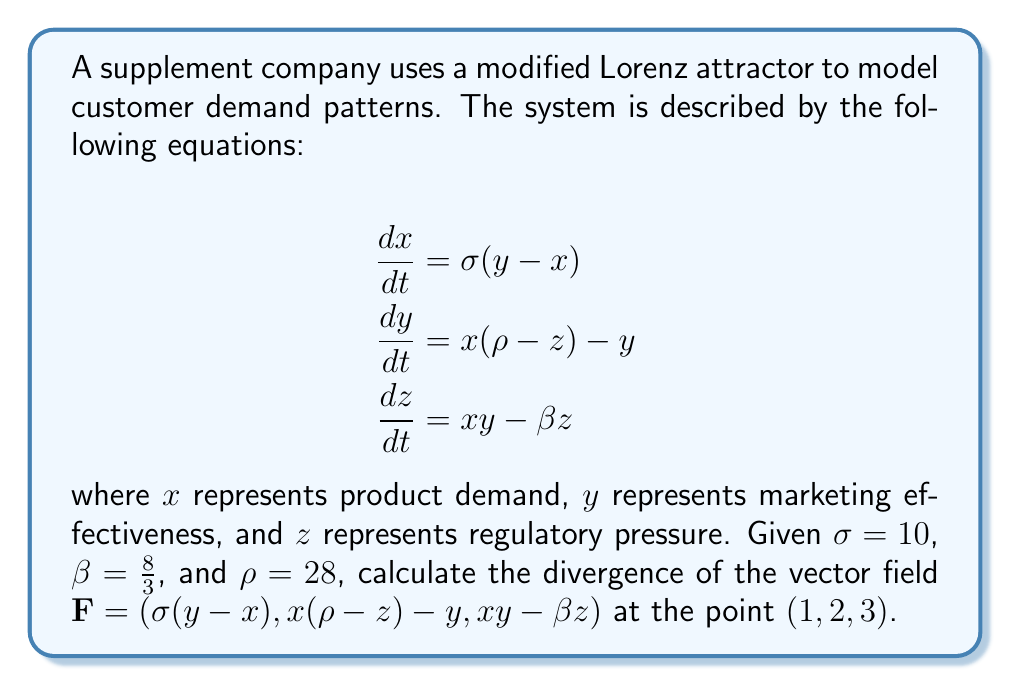Teach me how to tackle this problem. To solve this problem, we need to follow these steps:

1) The divergence of a vector field $\mathbf{F}(x, y, z) = (F_1, F_2, F_3)$ is given by:

   $$\nabla \cdot \mathbf{F} = \frac{\partial F_1}{\partial x} + \frac{\partial F_2}{\partial y} + \frac{\partial F_3}{\partial z}$$

2) In our case:
   $F_1 = \sigma(y - x)$
   $F_2 = x(\rho - z) - y$
   $F_3 = xy - \beta z$

3) Let's calculate each partial derivative:

   $\frac{\partial F_1}{\partial x} = -\sigma$
   
   $\frac{\partial F_2}{\partial y} = -1$
   
   $\frac{\partial F_3}{\partial z} = -\beta$

4) Now, we can substitute these values into the divergence formula:

   $$\nabla \cdot \mathbf{F} = -\sigma + (-1) + (-\beta)$$

5) Substitute the given values $\sigma = 10$ and $\beta = \frac{8}{3}$:

   $$\nabla \cdot \mathbf{F} = -10 + (-1) + (-\frac{8}{3})$$

6) Simplify:

   $$\nabla \cdot \mathbf{F} = -10 - 1 - \frac{8}{3} = -11 - \frac{8}{3} = -\frac{41}{3}$$

Note that the divergence is constant for this vector field, so it's the same at all points, including $(1, 2, 3)$.
Answer: $-\frac{41}{3}$ 